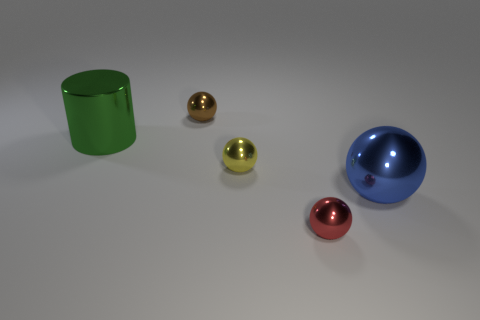How many other things are the same color as the shiny cylinder?
Provide a succinct answer. 0. What size is the yellow sphere that is to the left of the metallic thing that is right of the red sphere?
Offer a very short reply. Small. Is the large object that is behind the big blue thing made of the same material as the tiny brown object?
Provide a succinct answer. Yes. What shape is the big shiny thing that is left of the brown thing?
Make the answer very short. Cylinder. What number of other red metallic balls have the same size as the red sphere?
Provide a short and direct response. 0. The brown sphere has what size?
Offer a terse response. Small. There is a yellow shiny object; what number of yellow things are behind it?
Give a very brief answer. 0. There is a blue thing that is the same material as the green thing; what shape is it?
Offer a very short reply. Sphere. Is the number of tiny red shiny spheres that are to the left of the large green metal cylinder less than the number of small red balls that are behind the tiny yellow metal object?
Offer a very short reply. No. Is the number of small metal objects greater than the number of balls?
Provide a short and direct response. No. 